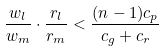<formula> <loc_0><loc_0><loc_500><loc_500>\frac { w _ { l } } { w _ { m } } \cdot \frac { r _ { l } } { r _ { m } } < \frac { ( n - 1 ) c _ { p } } { c _ { g } + c _ { r } }</formula> 